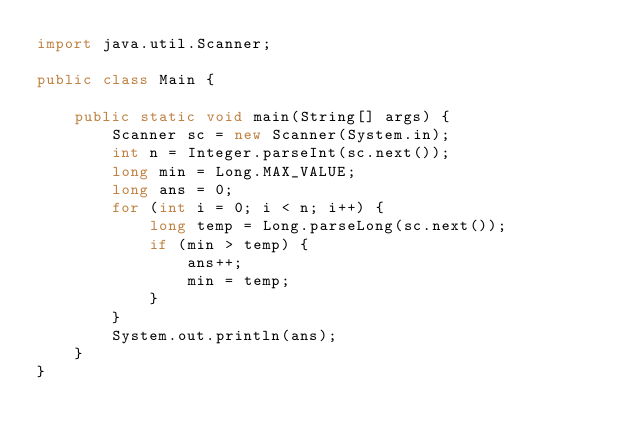Convert code to text. <code><loc_0><loc_0><loc_500><loc_500><_Java_>import java.util.Scanner;

public class Main {

    public static void main(String[] args) {
        Scanner sc = new Scanner(System.in);
        int n = Integer.parseInt(sc.next());
        long min = Long.MAX_VALUE;
        long ans = 0;
        for (int i = 0; i < n; i++) {
            long temp = Long.parseLong(sc.next());
            if (min > temp) {
                ans++;
                min = temp;
            }
        }
        System.out.println(ans);
    }
}
</code> 